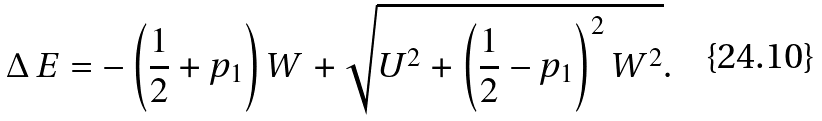<formula> <loc_0><loc_0><loc_500><loc_500>\Delta \, E = - \left ( \frac { 1 } { 2 } + p _ { 1 } \right ) W + \sqrt { U ^ { 2 } + \left ( \frac { 1 } { 2 } - p _ { 1 } \right ) ^ { 2 } W ^ { 2 } } .</formula> 